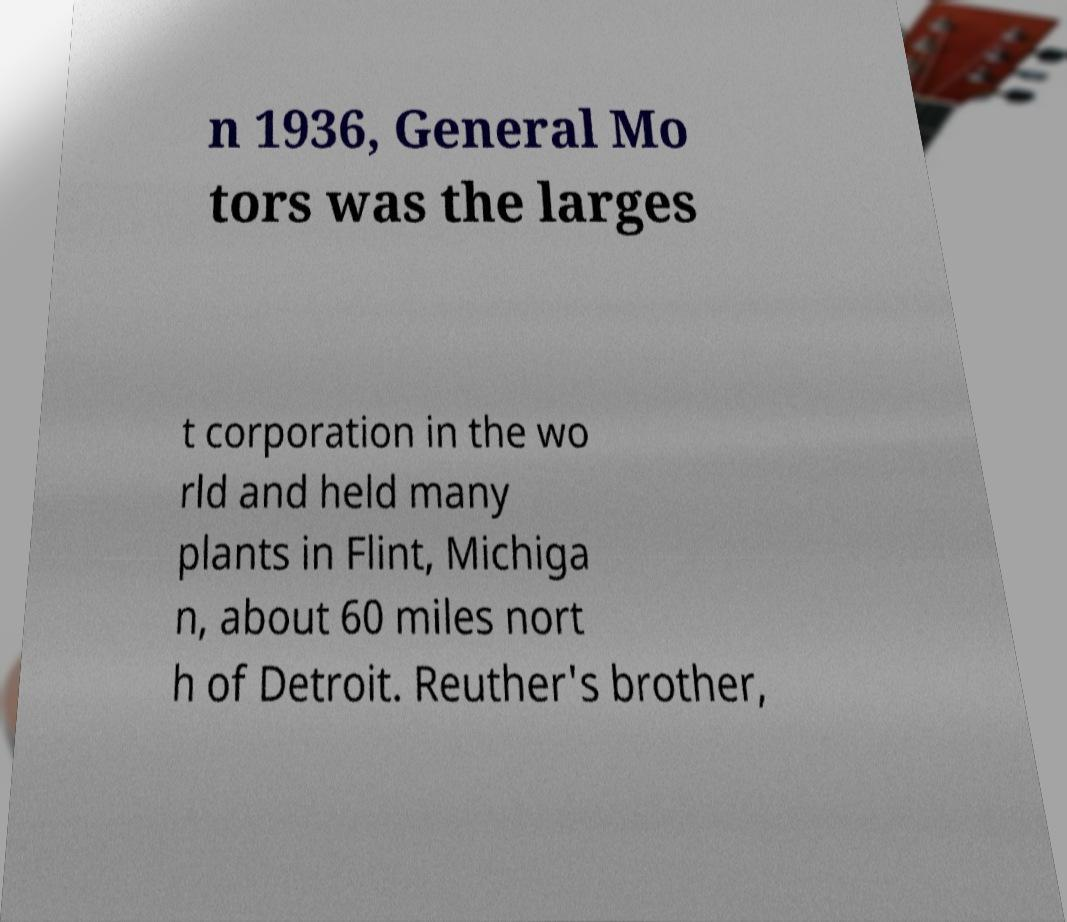Please identify and transcribe the text found in this image. n 1936, General Mo tors was the larges t corporation in the wo rld and held many plants in Flint, Michiga n, about 60 miles nort h of Detroit. Reuther's brother, 